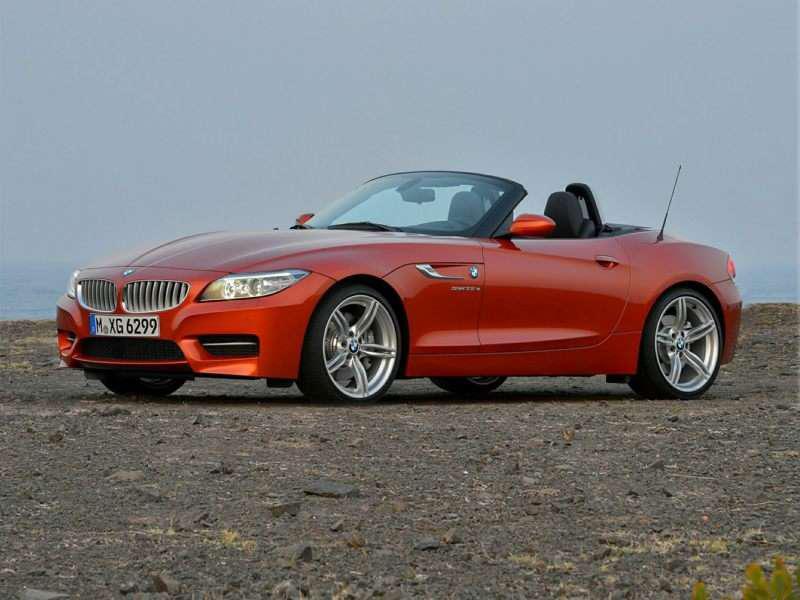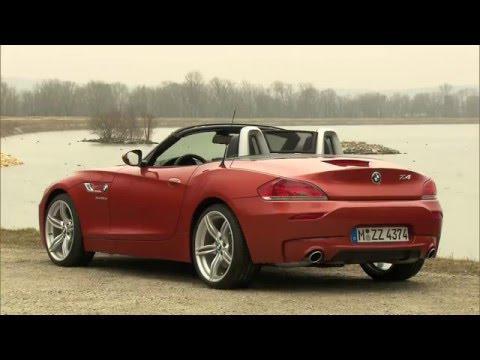The first image is the image on the left, the second image is the image on the right. Analyze the images presented: Is the assertion "In at least one image  there is a orange convertible top car with thin tires and silver rims pointed  left." valid? Answer yes or no. Yes. The first image is the image on the left, the second image is the image on the right. Examine the images to the left and right. Is the description "One image has an orange BMW facing the right." accurate? Answer yes or no. No. 